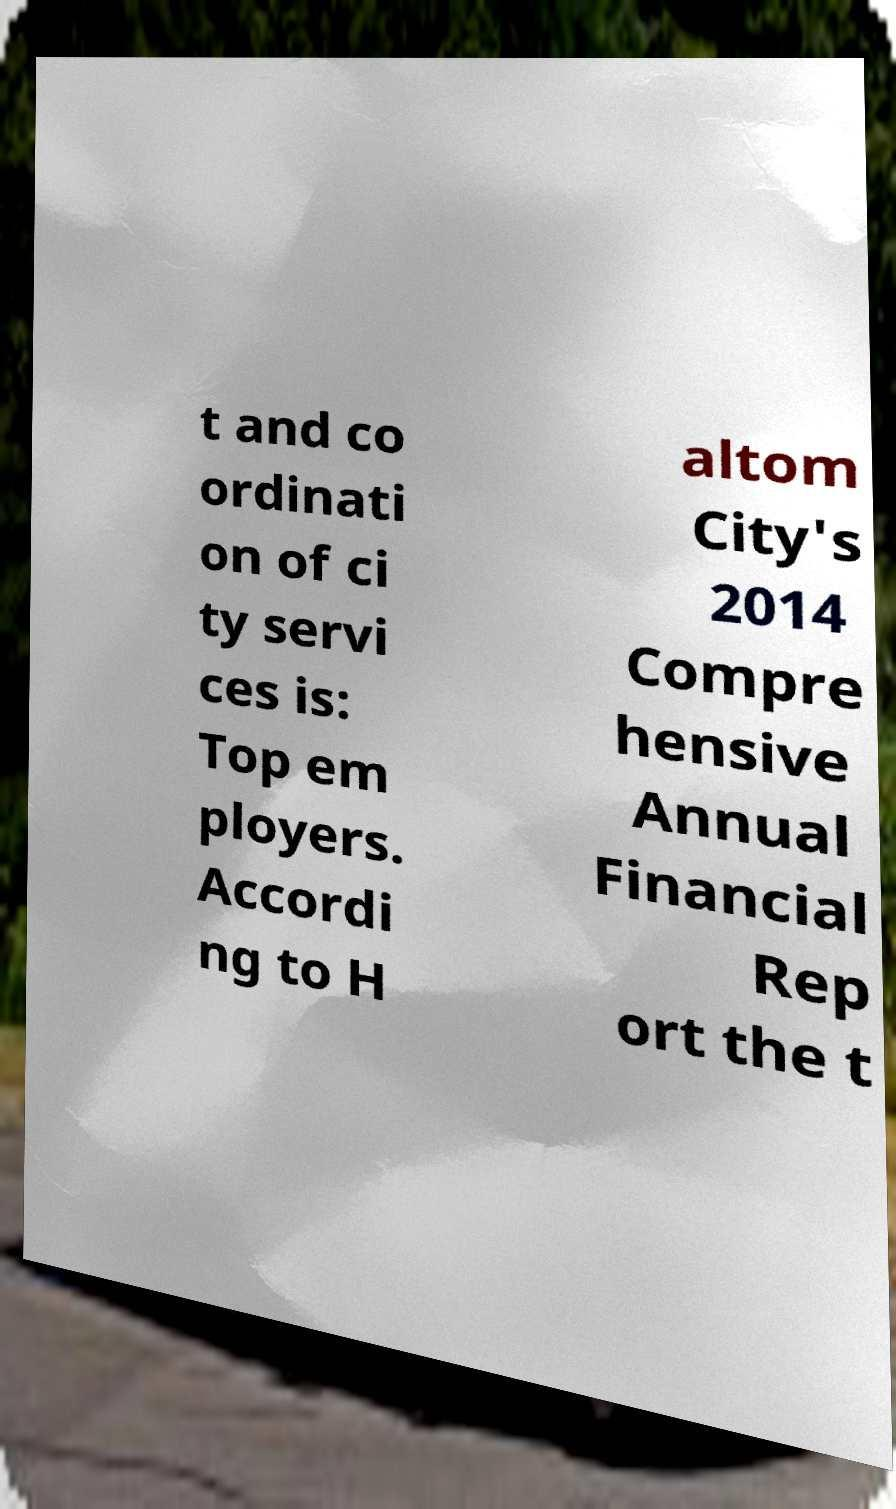I need the written content from this picture converted into text. Can you do that? t and co ordinati on of ci ty servi ces is: Top em ployers. Accordi ng to H altom City's 2014 Compre hensive Annual Financial Rep ort the t 